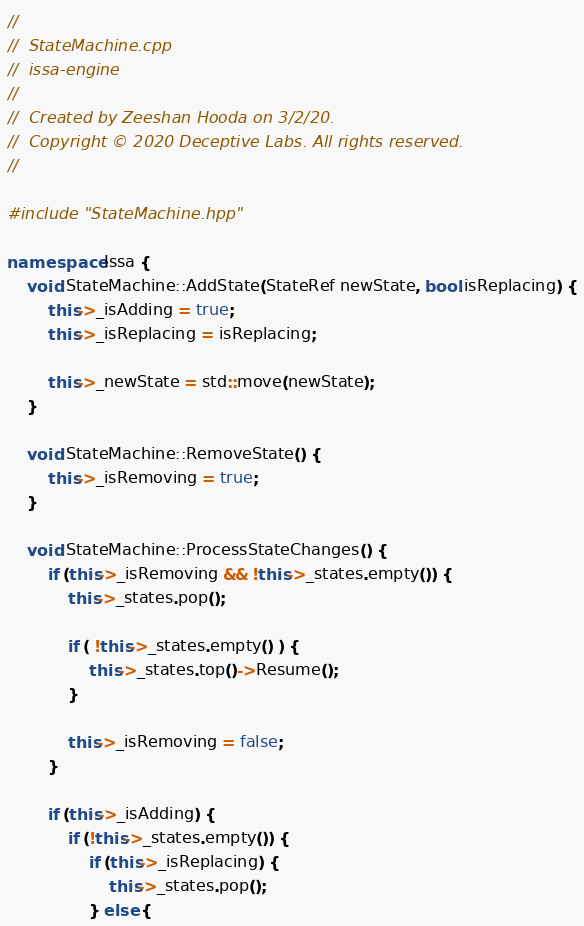<code> <loc_0><loc_0><loc_500><loc_500><_C++_>//
//  StateMachine.cpp
//  issa-engine
//
//  Created by Zeeshan Hooda on 3/2/20.
//  Copyright © 2020 Deceptive Labs. All rights reserved.
//

#include "StateMachine.hpp"

namespace Issa {
    void StateMachine::AddState(StateRef newState, bool isReplacing) {
        this->_isAdding = true;
        this->_isReplacing = isReplacing;
        
        this->_newState = std::move(newState);
    }
    
    void StateMachine::RemoveState() {
        this->_isRemoving = true;
    }

    void StateMachine::ProcessStateChanges() {
        if (this->_isRemoving && !this->_states.empty()) {
            this->_states.pop();
            
            if ( !this->_states.empty() ) {
                this->_states.top()->Resume();
            }
            
            this->_isRemoving = false;
        }
        
        if (this->_isAdding) {
            if (!this->_states.empty()) {
                if (this->_isReplacing) {
                    this->_states.pop();
                } else {</code> 